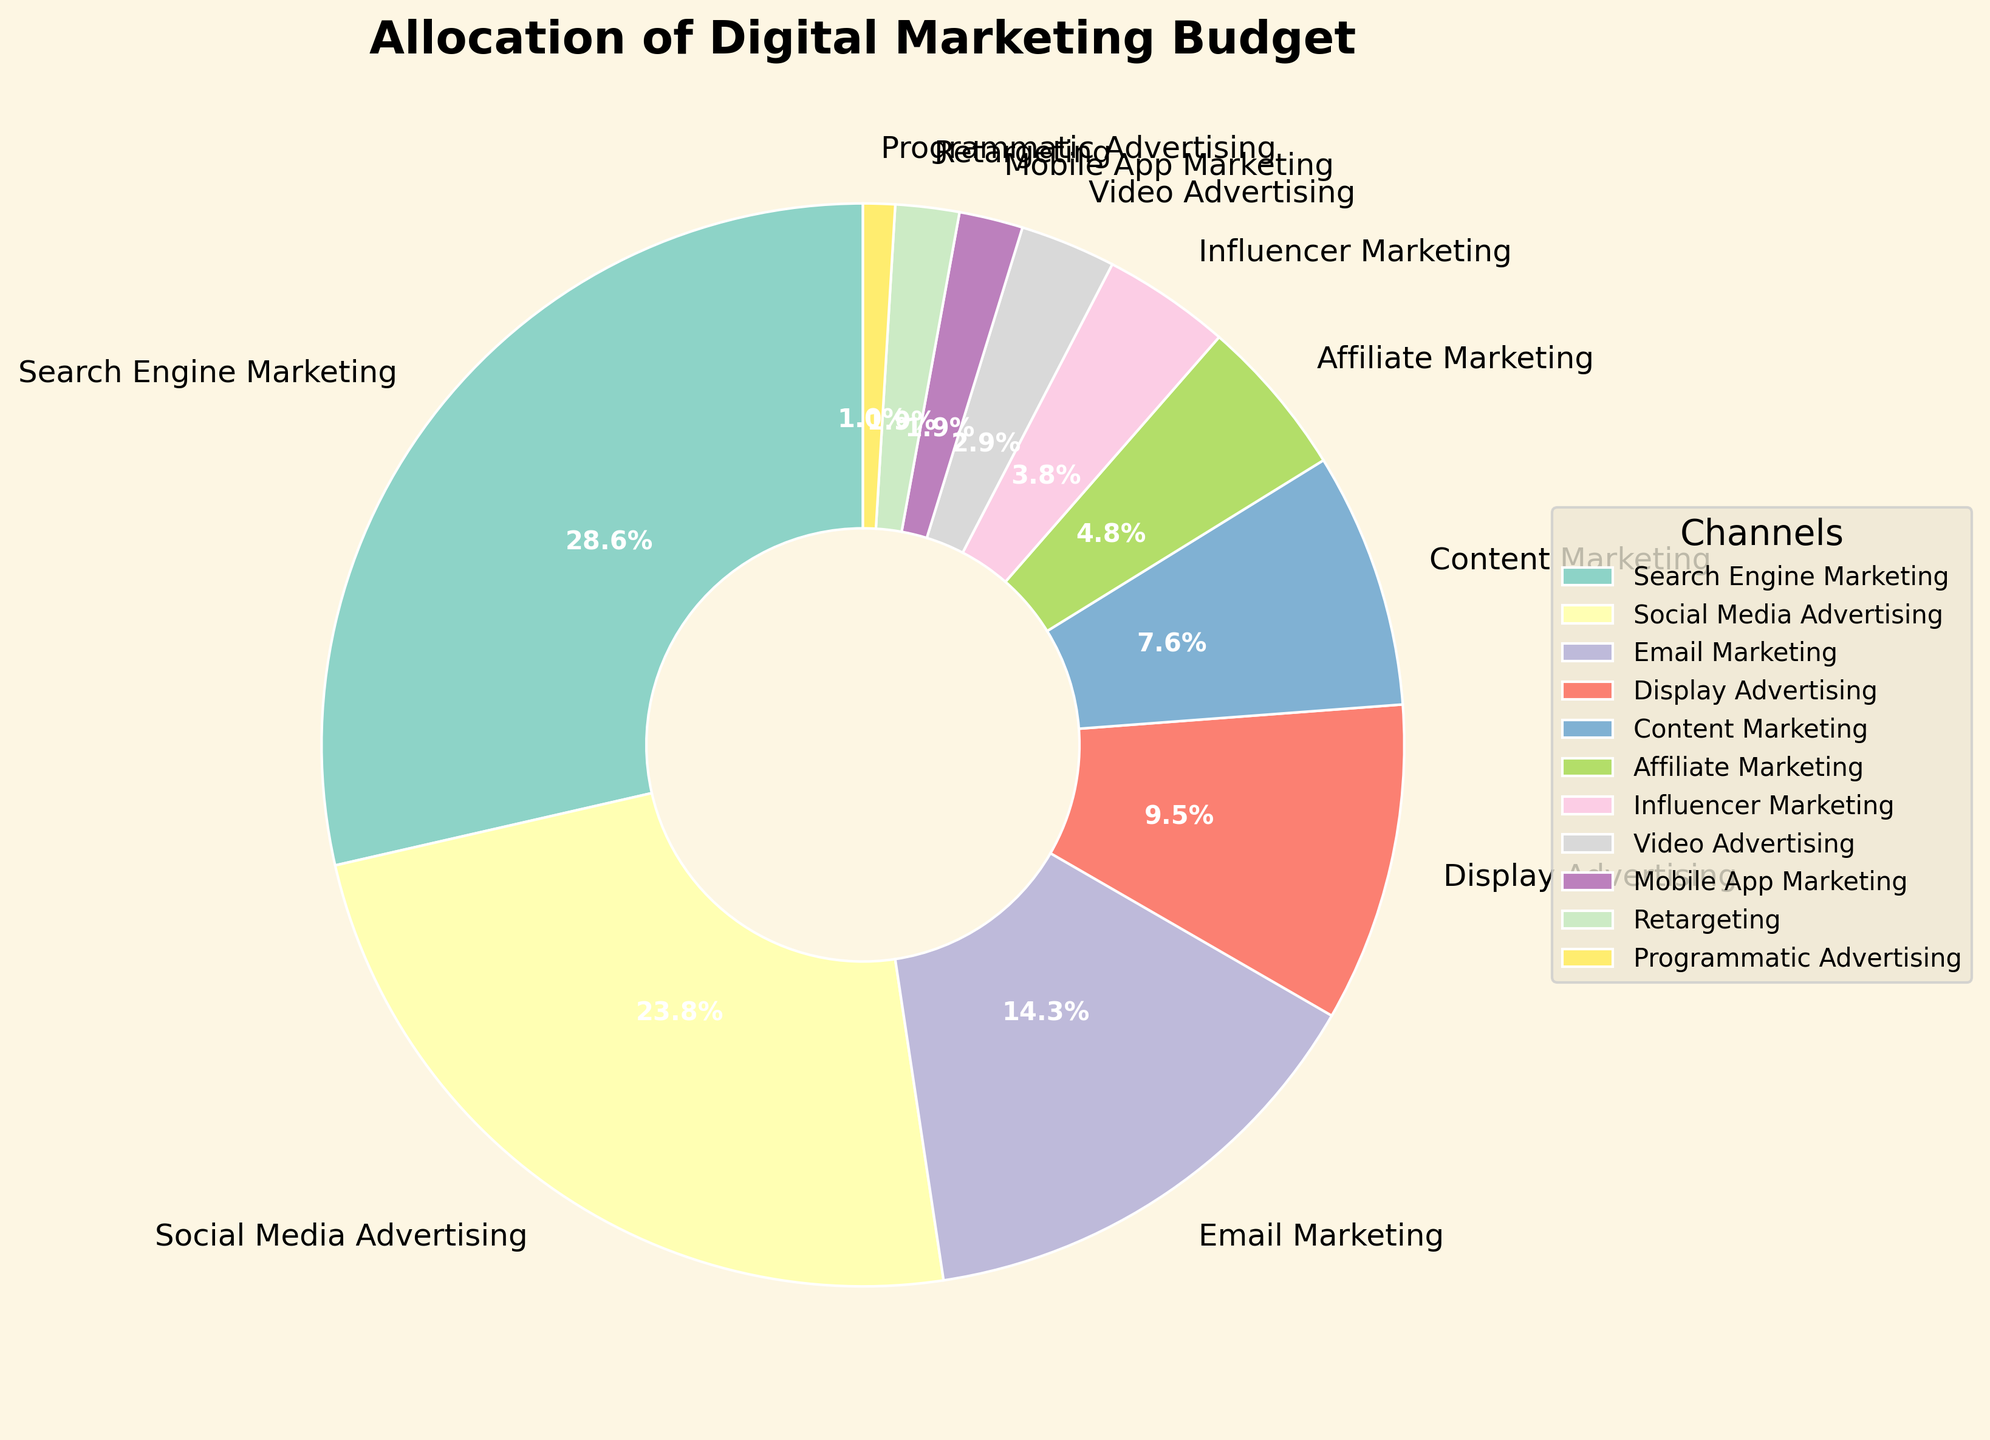What percentage of the digital marketing budget is allocated to Search Engine Marketing and Social Media Advertising combined? To find the combined percentage, add the percentages allocated to Search Engine Marketing (30%) and Social Media Advertising (25%). So, 30% + 25% = 55%.
Answer: 55% Which online channel receives the smallest proportion of the digital marketing budget? By looking at the wedges in the pie chart, we see that Programmatic Advertising has the smallest segment with 1%.
Answer: Programmatic Advertising Is the budget allocated for Mobile App Marketing greater than or equal to the budget for Retargeting? Both Mobile App Marketing and Retargeting are allocated 2% each, so the budget for Mobile App Marketing is equal to the budget for Retargeting.
Answer: Equal What is the difference in the percentage allocation between Content Marketing and Display Advertising? Display Advertising is allocated 10%, and Content Marketing is allocated 8%. The difference is 10% - 8%, which equals 2%.
Answer: 2% How do the combined budgets of Influencer Marketing and Video Advertising compare to Email Marketing? Influencer Marketing has 4%, and Video Advertising has 3%. The combined total is 4% + 3%, which equals 7%. Email Marketing has 15%, so 15% - 7% equals 8% less for Influencer and Video combined compared to Email Marketing.
Answer: 8% less What is the rank of Email Marketing in terms of budget allocation from highest to lowest? By referring to the figure, the ranks are: 1) Search Engine Marketing (30%), 2) Social Media Advertising (25%), 3) Email Marketing (15%). Therefore, Email Marketing is in the third position.
Answer: 3rd Which channel has a larger budget allocation: Affiliate Marketing or Influencer Marketing? Affiliate Marketing is allocated 5%, while Influencer Marketing is allocated 4%. Therefore, Affiliate Marketing has a larger budget allocation.
Answer: Affiliate Marketing What fraction of the total budget is allocated to Retargeting and Programmatic Advertising together? Retargeting is allocated 2%, and Programmatic Advertising is allocated 1%. The combined percentage is 2% + 1%, which equals 3%. Hence the fraction is 3%.
Answer: 3% What is the combined allocation for channels with less than 5% of the budget each? Channels under 5% are Influencer Marketing (4%), Video Advertising (3%), Mobile App Marketing (2%), Retargeting (2%), and Programmatic Advertising (1%). Summing these, 4% + 3% + 2% + 2% + 1% = 12%.
Answer: 12% Which portion of the pie chart has the most vibrant color among the least allocated channels? Among the least allocated channels (less than 5%), Influencer Marketing with 4% seems to have a more vibrant color compared to the others with smaller percentages.
Answer: Influencer Marketing 